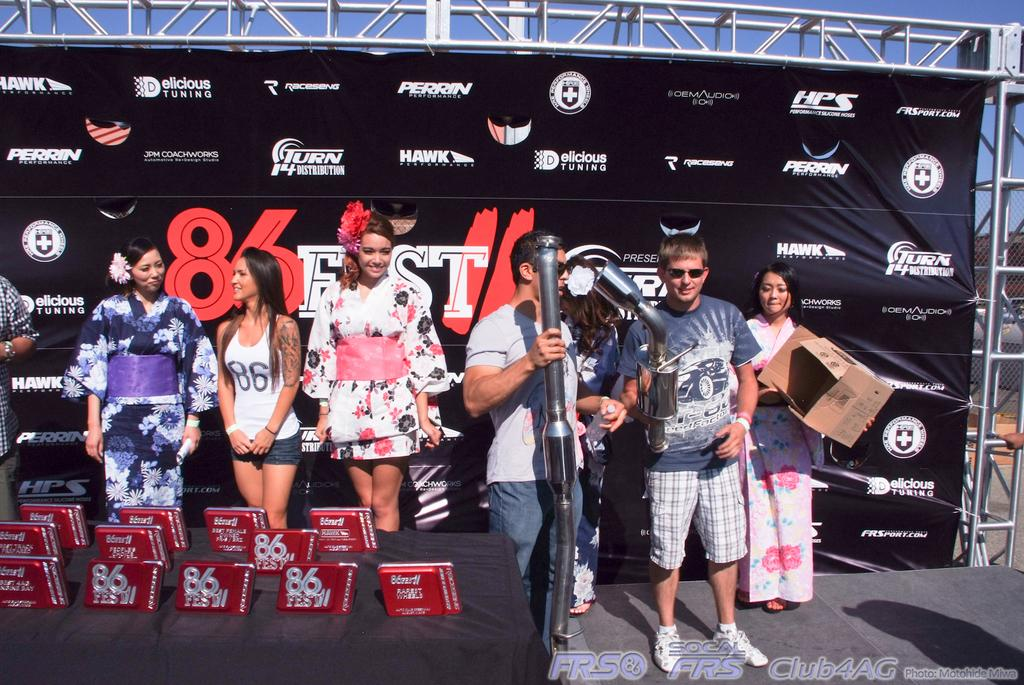<image>
Write a terse but informative summary of the picture. A diverse group of people hang around a table laden with 86 Fest merchandise. 